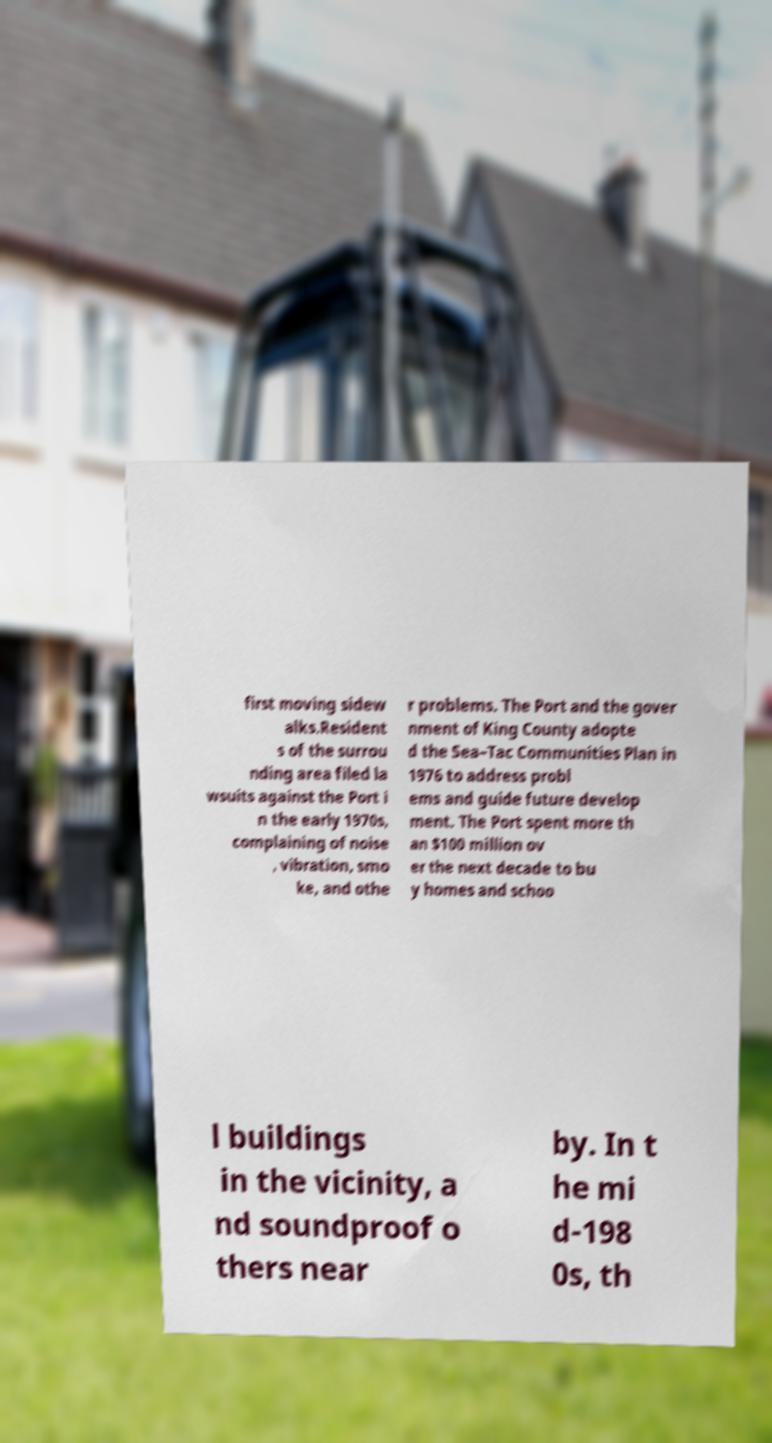Can you accurately transcribe the text from the provided image for me? first moving sidew alks.Resident s of the surrou nding area filed la wsuits against the Port i n the early 1970s, complaining of noise , vibration, smo ke, and othe r problems. The Port and the gover nment of King County adopte d the Sea–Tac Communities Plan in 1976 to address probl ems and guide future develop ment. The Port spent more th an $100 million ov er the next decade to bu y homes and schoo l buildings in the vicinity, a nd soundproof o thers near by. In t he mi d-198 0s, th 